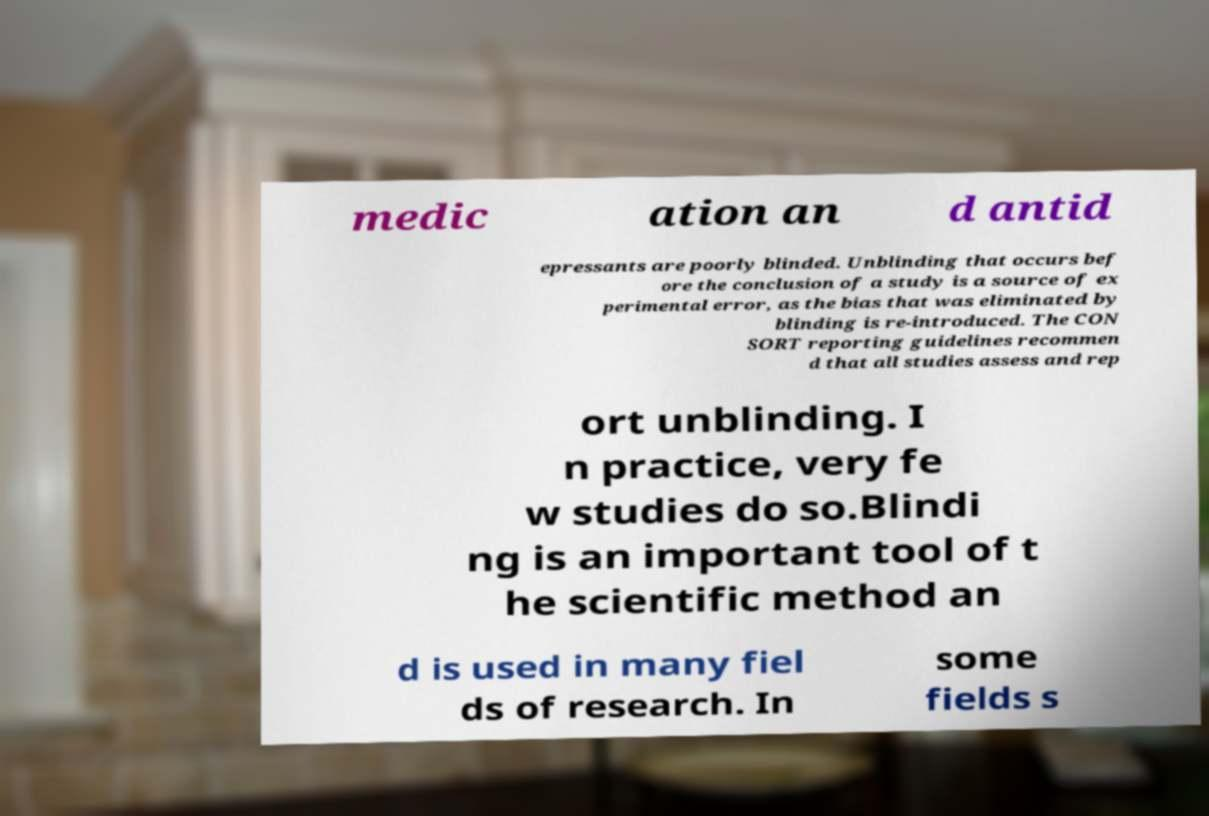Please identify and transcribe the text found in this image. medic ation an d antid epressants are poorly blinded. Unblinding that occurs bef ore the conclusion of a study is a source of ex perimental error, as the bias that was eliminated by blinding is re-introduced. The CON SORT reporting guidelines recommen d that all studies assess and rep ort unblinding. I n practice, very fe w studies do so.Blindi ng is an important tool of t he scientific method an d is used in many fiel ds of research. In some fields s 